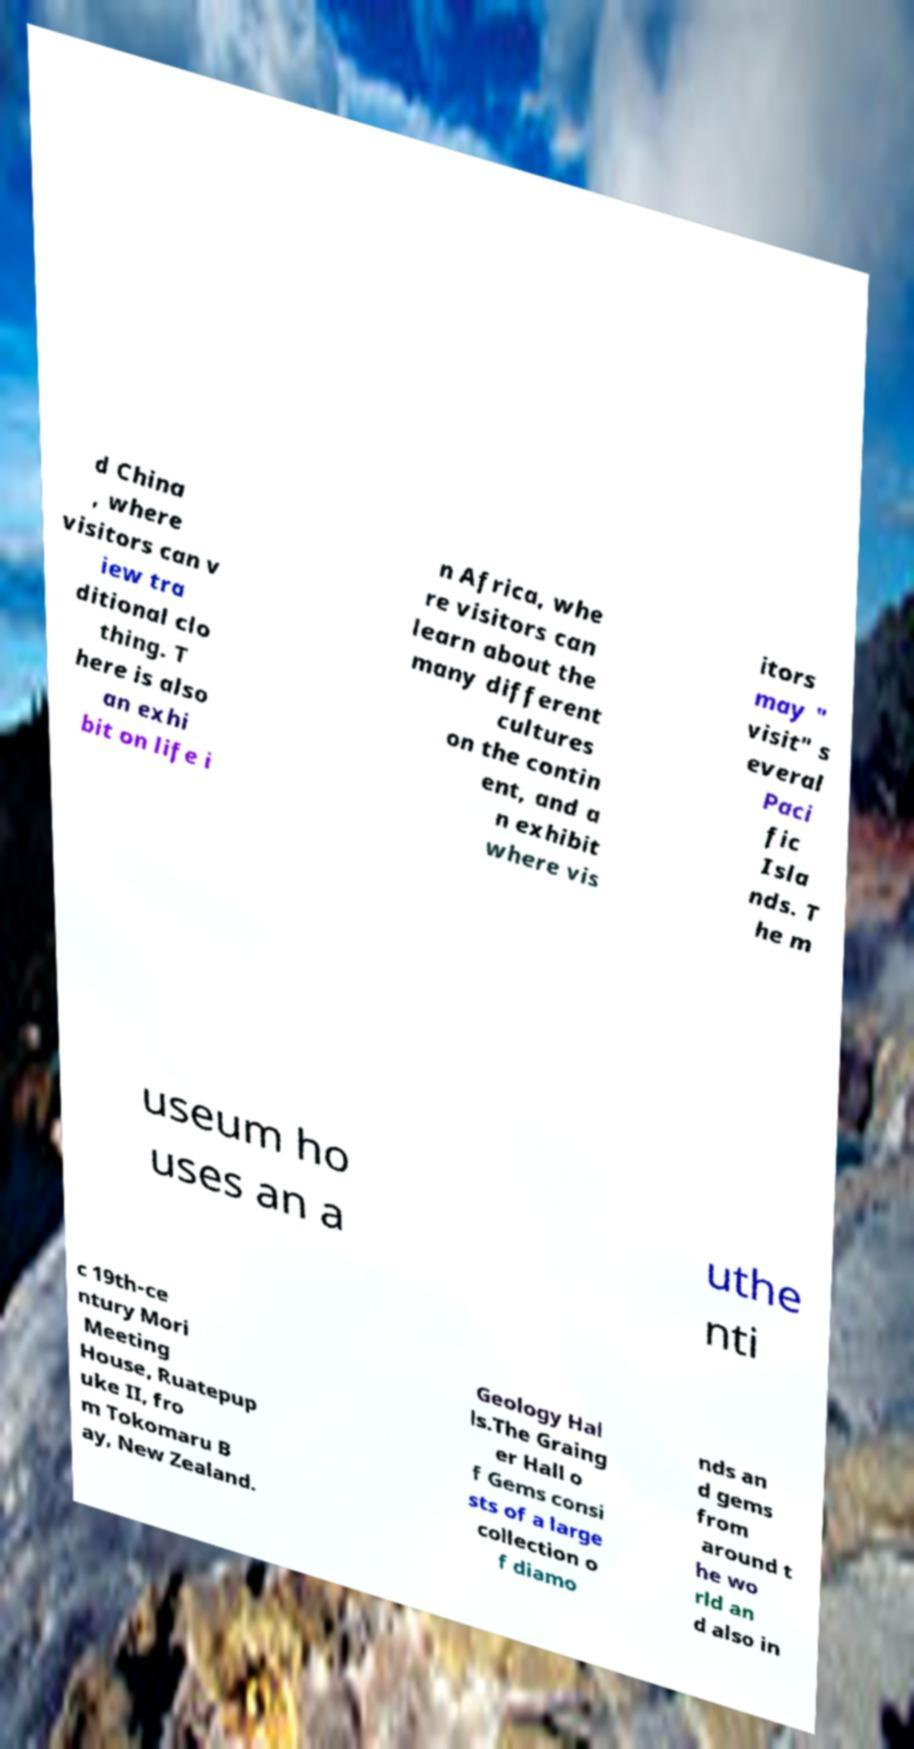Please identify and transcribe the text found in this image. d China , where visitors can v iew tra ditional clo thing. T here is also an exhi bit on life i n Africa, whe re visitors can learn about the many different cultures on the contin ent, and a n exhibit where vis itors may " visit" s everal Paci fic Isla nds. T he m useum ho uses an a uthe nti c 19th-ce ntury Mori Meeting House, Ruatepup uke II, fro m Tokomaru B ay, New Zealand. Geology Hal ls.The Graing er Hall o f Gems consi sts of a large collection o f diamo nds an d gems from around t he wo rld an d also in 